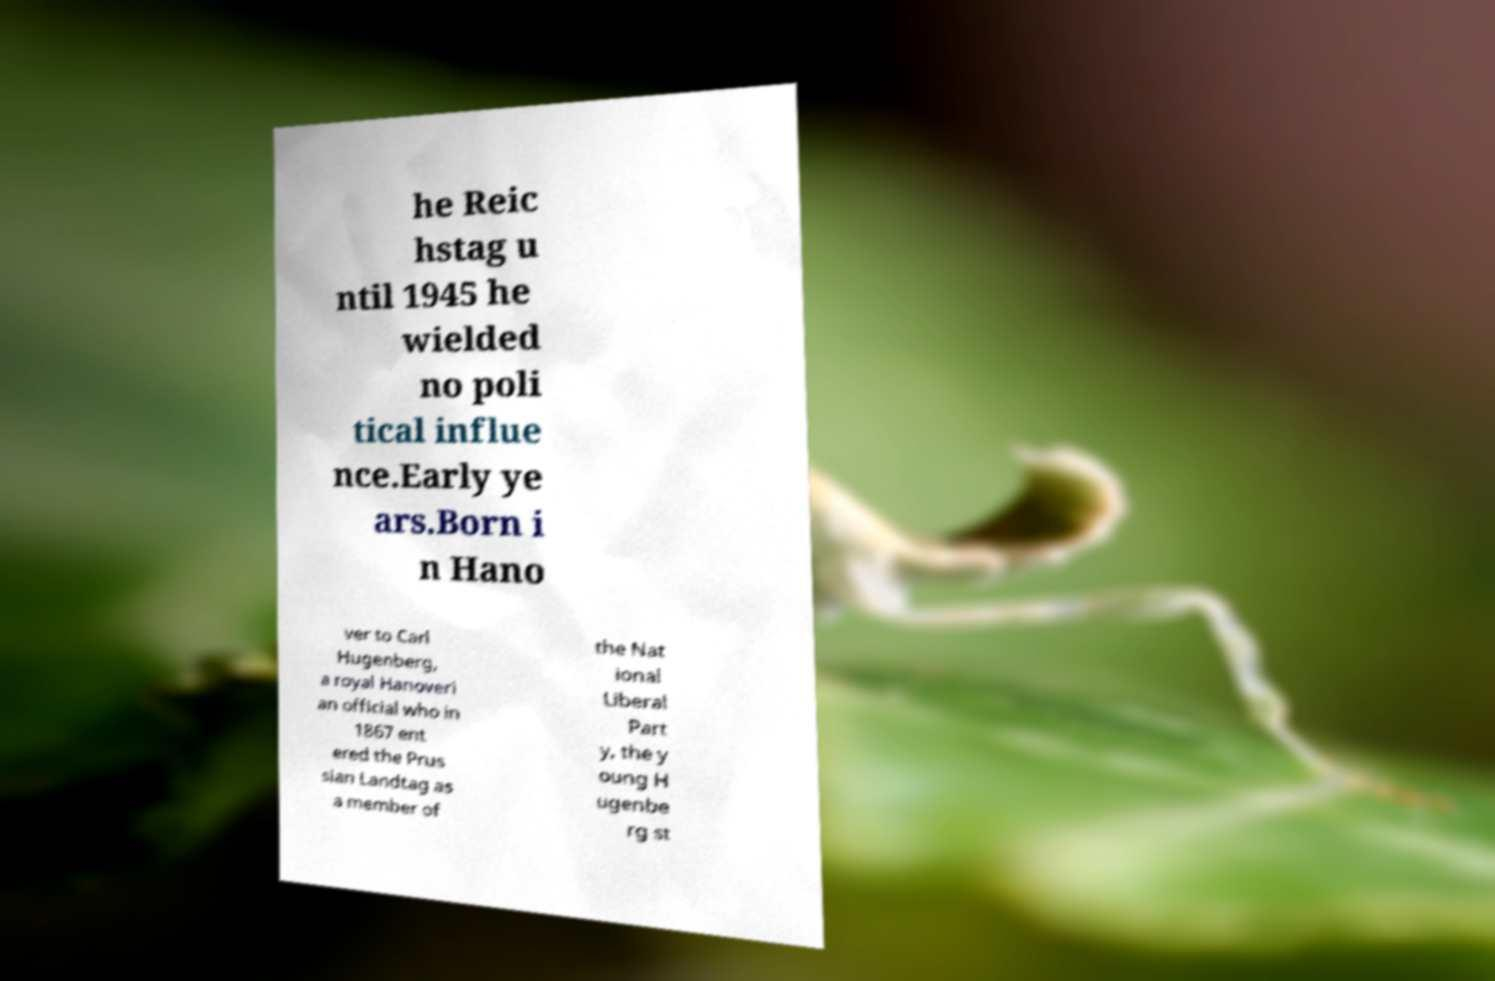Could you assist in decoding the text presented in this image and type it out clearly? he Reic hstag u ntil 1945 he wielded no poli tical influe nce.Early ye ars.Born i n Hano ver to Carl Hugenberg, a royal Hanoveri an official who in 1867 ent ered the Prus sian Landtag as a member of the Nat ional Liberal Part y, the y oung H ugenbe rg st 